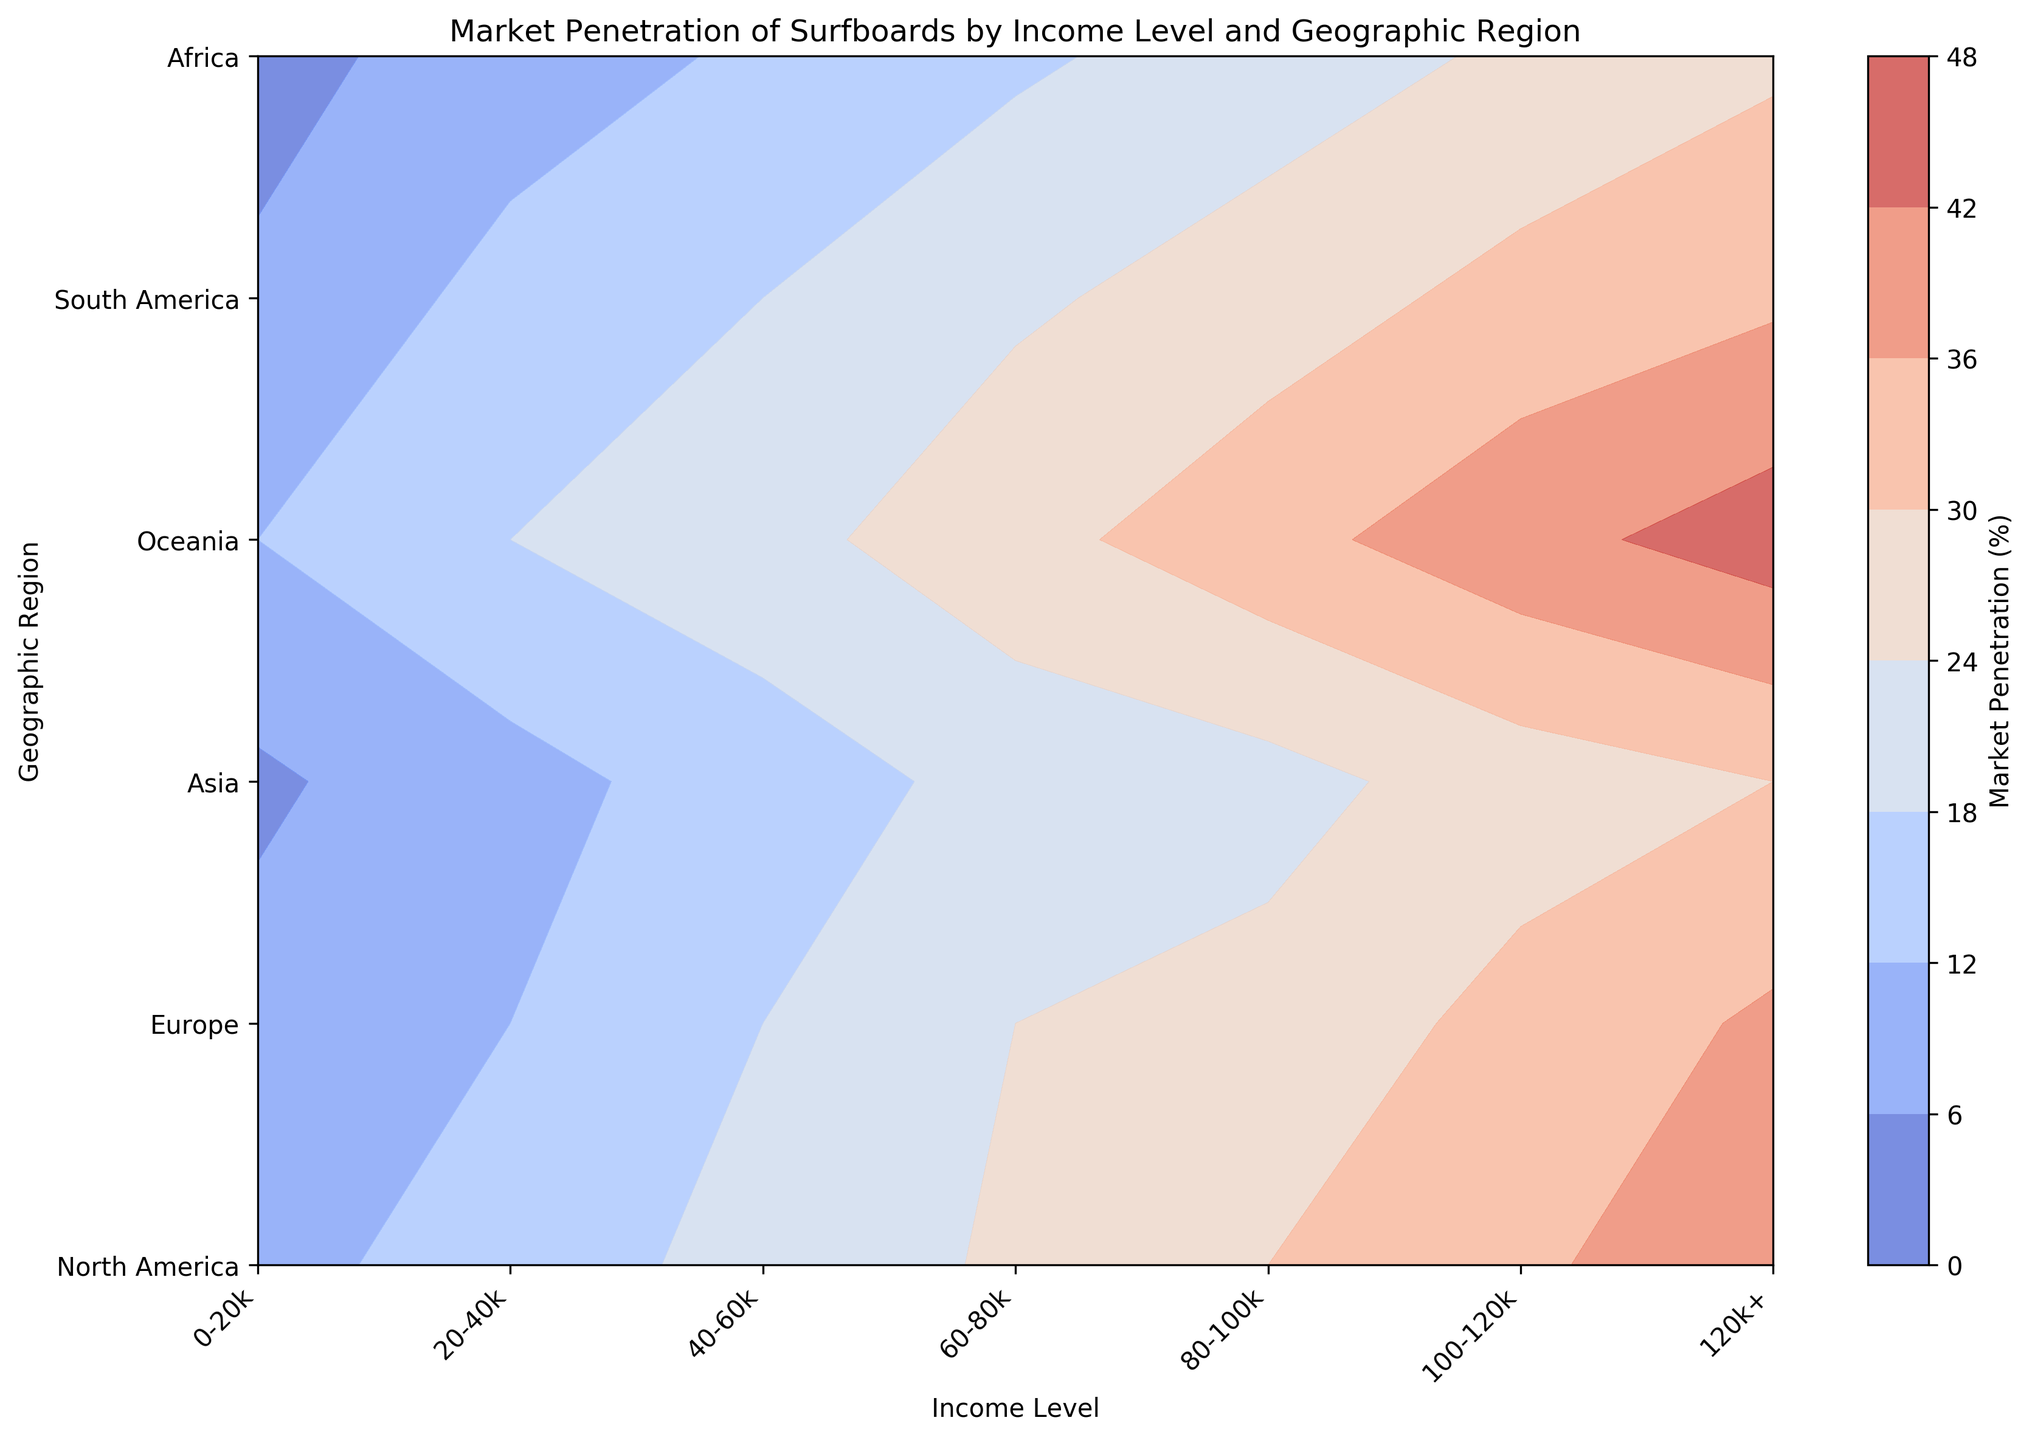Which geographic region has the highest market penetration for the income level of 120k+? First, locate the column representing the income level of 120k+ on the x-axis. Then, find the region on the y-axis and look at the corresponding color intensity and contour lines. Oceania has the highest market penetration for the income level of 120k+.
Answer: Oceania Is the market penetration higher in Europe or Asia for the income level of 60-80k? Identify the column representing the income level of 60-80k on the x-axis. Then, compare the values and color intensities for Europe and Asia within this column. The market penetration in Europe for the income level of 60-80k is higher than in Asia.
Answer: Europe Which income level has the lowest market penetration in North America? Locate the row for North America on the y-axis and analyze the intensity of the colors across all income levels within this row. The income level 0-20k has the lowest market penetration in North America.
Answer: 0-20k What is the average market penetration in South America across all income levels? Identify the row for South America on the y-axis and extract the market penetration values for all income levels. Then, sum them up and divide by the number of income levels. The values are 7, 14, 18, 23, 27, 32, and 35. Sum = 156; Average = 156/7 ≈ 22.3.
Answer: 22.3 How does the market penetration for the income level 80-100k in Oceania compare to that in Africa? Find the column corresponding to the income level 80-100k on the x-axis, then note the market penetration values for Oceania and Africa. The market penetration in Oceania for 80-100k is visibly higher than in Africa.
Answer: Oceania What is the difference in market penetration between the highest and lowest regions for the income level of 40-60k? Identify the column for 40-60k on the x-axis and extract the market penetration values for all geographic regions. The values are 20 (North America), 18 (Europe), 15 (Asia), 22 (Oceania), 18 (South America), and 13 (Africa). The highest is 22 (Oceania), and the lowest is 13 (Africa). Difference = 22 - 13 = 9.
Answer: 9 What region has the highest market penetration for the income range 0-20k, and how much is it? First, locate the column for the income level 0-20k on the x-axis. Compare the market penetration values for all regions. Oceania has the highest market penetration at 12.
Answer: Oceania, 12 What is the general trend in market penetration as income levels increase in Europe? Locate the row for Europe and observe the color intensities from left to right as income levels increase. The market penetration generally increases as income levels go up.
Answer: Increasing Which region shows the least variation in market penetration across different income levels? Compare the consistency of colors and contour lines across income levels for each region. North America has the least variation in market penetration across different income levels.
Answer: North America 